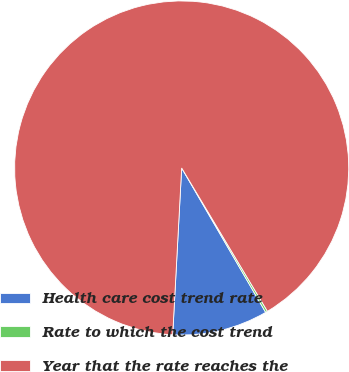<chart> <loc_0><loc_0><loc_500><loc_500><pie_chart><fcel>Health care cost trend rate<fcel>Rate to which the cost trend<fcel>Year that the rate reaches the<nl><fcel>9.24%<fcel>0.2%<fcel>90.57%<nl></chart> 